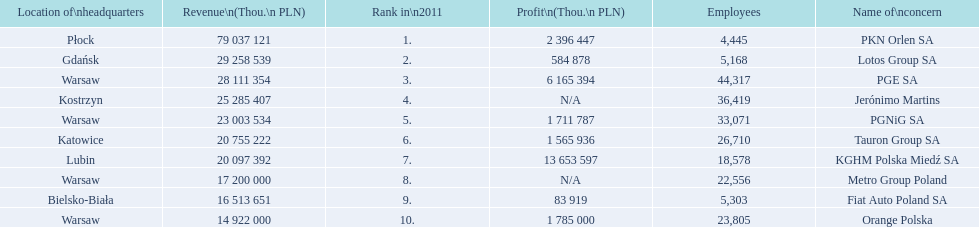What company has the top number of employees? PGE SA. 